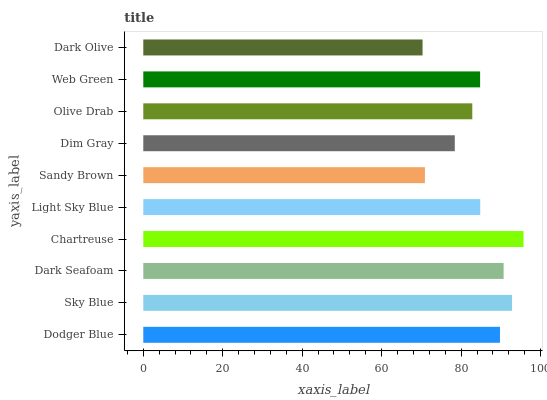Is Dark Olive the minimum?
Answer yes or no. Yes. Is Chartreuse the maximum?
Answer yes or no. Yes. Is Sky Blue the minimum?
Answer yes or no. No. Is Sky Blue the maximum?
Answer yes or no. No. Is Sky Blue greater than Dodger Blue?
Answer yes or no. Yes. Is Dodger Blue less than Sky Blue?
Answer yes or no. Yes. Is Dodger Blue greater than Sky Blue?
Answer yes or no. No. Is Sky Blue less than Dodger Blue?
Answer yes or no. No. Is Light Sky Blue the high median?
Answer yes or no. Yes. Is Web Green the low median?
Answer yes or no. Yes. Is Chartreuse the high median?
Answer yes or no. No. Is Sandy Brown the low median?
Answer yes or no. No. 